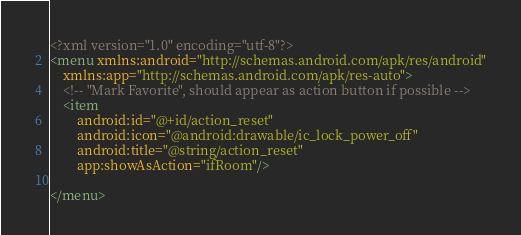<code> <loc_0><loc_0><loc_500><loc_500><_XML_><?xml version="1.0" encoding="utf-8"?>
<menu xmlns:android="http://schemas.android.com/apk/res/android"
    xmlns:app="http://schemas.android.com/apk/res-auto">
    <!-- "Mark Favorite", should appear as action button if possible -->
    <item
        android:id="@+id/action_reset"
        android:icon="@android:drawable/ic_lock_power_off"
        android:title="@string/action_reset"
        app:showAsAction="ifRoom"/>

</menu></code> 